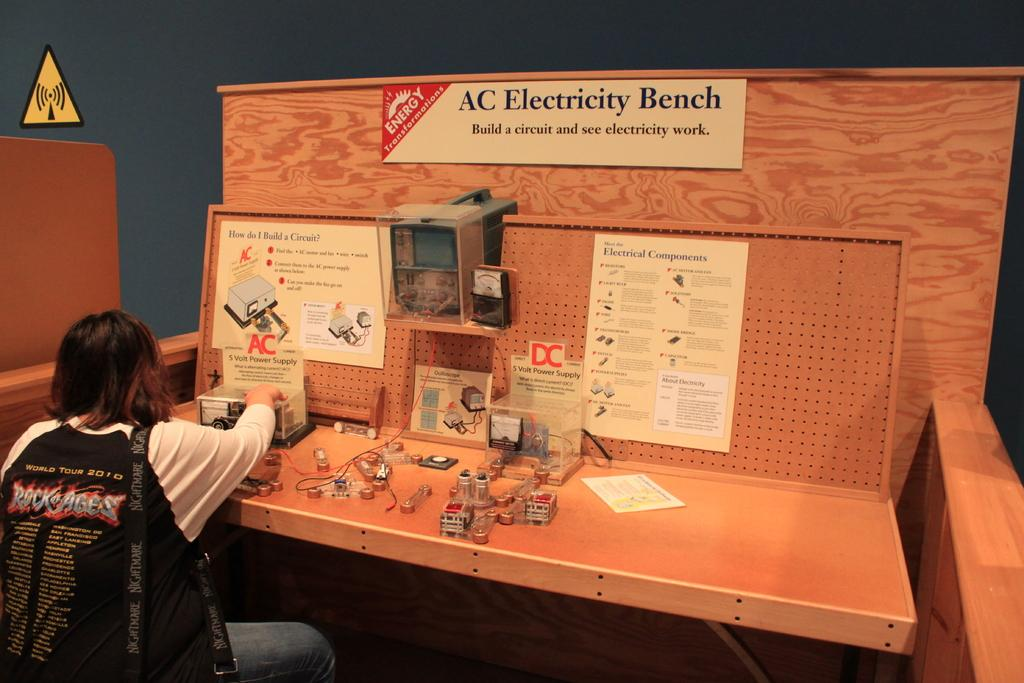What is the person in the image doing? The person is sitting in front of a table. What can be seen on the table? There are items on the table. What is the purpose of the board with writing on it? The board with "electricity bench" written on it indicates that the table is an electricity bench. How many cattle are visible in the image? There are no cattle present in the image. What type of door can be seen in the image? There is no door visible in the image. 